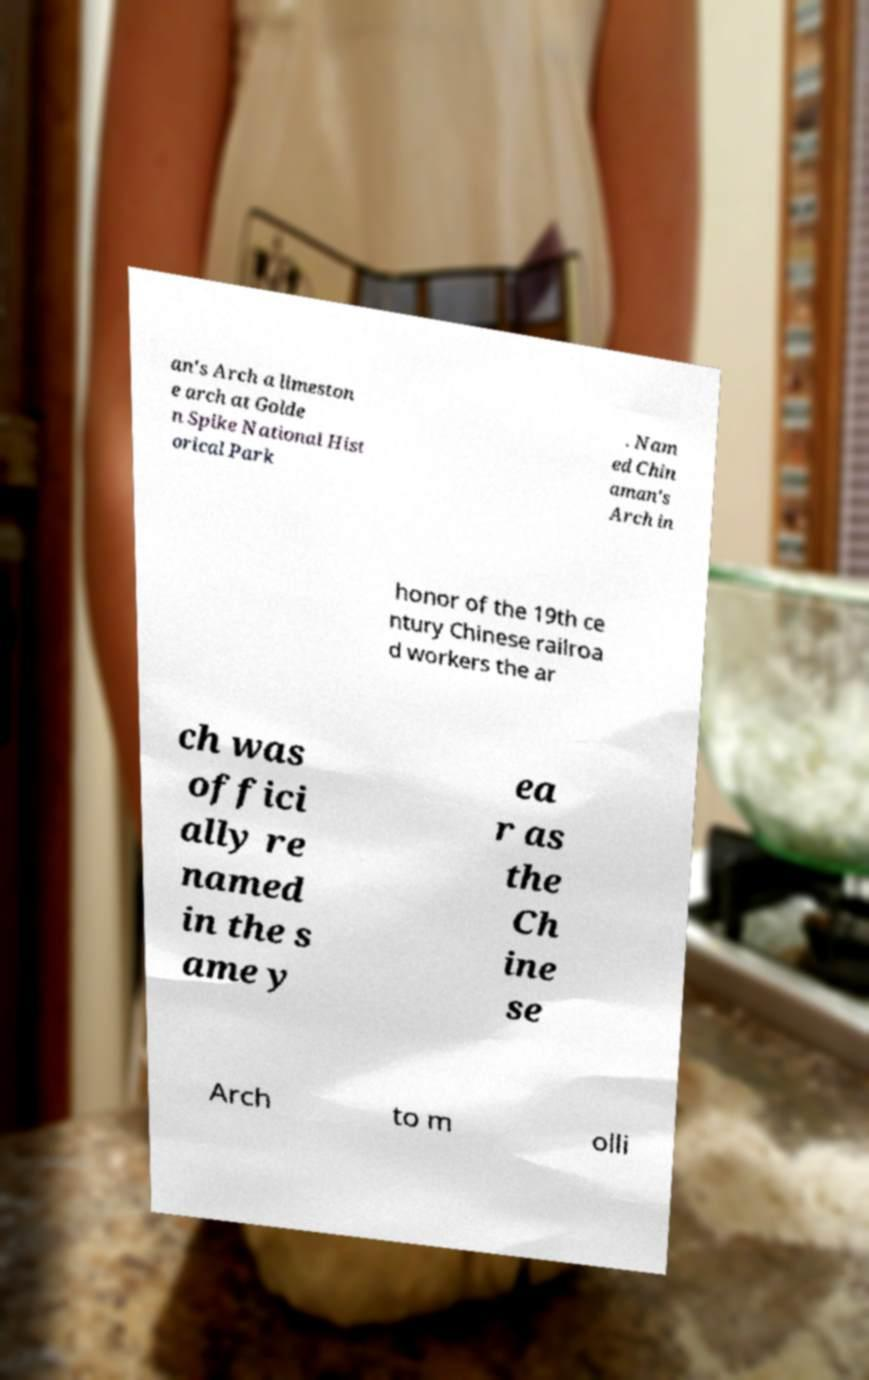What messages or text are displayed in this image? I need them in a readable, typed format. an's Arch a limeston e arch at Golde n Spike National Hist orical Park . Nam ed Chin aman's Arch in honor of the 19th ce ntury Chinese railroa d workers the ar ch was offici ally re named in the s ame y ea r as the Ch ine se Arch to m olli 